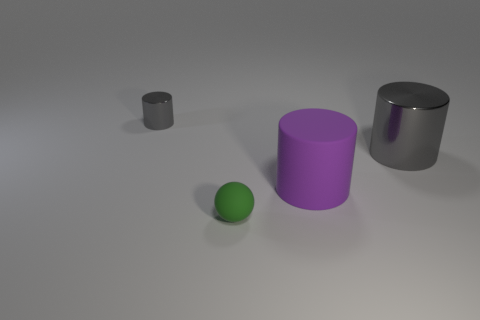Add 3 big rubber objects. How many objects exist? 7 Subtract all balls. How many objects are left? 3 Subtract 0 purple balls. How many objects are left? 4 Subtract all big gray shiny things. Subtract all spheres. How many objects are left? 2 Add 1 tiny metal objects. How many tiny metal objects are left? 2 Add 2 purple matte cylinders. How many purple matte cylinders exist? 3 